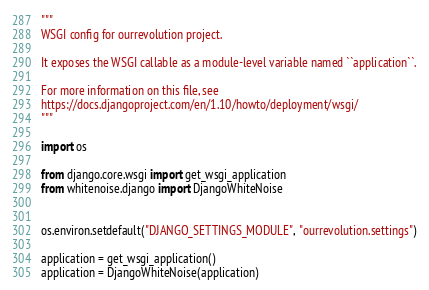<code> <loc_0><loc_0><loc_500><loc_500><_Python_>"""
WSGI config for ourrevolution project.

It exposes the WSGI callable as a module-level variable named ``application``.

For more information on this file, see
https://docs.djangoproject.com/en/1.10/howto/deployment/wsgi/
"""

import os

from django.core.wsgi import get_wsgi_application
from whitenoise.django import DjangoWhiteNoise


os.environ.setdefault("DJANGO_SETTINGS_MODULE", "ourrevolution.settings")

application = get_wsgi_application()
application = DjangoWhiteNoise(application)
</code> 